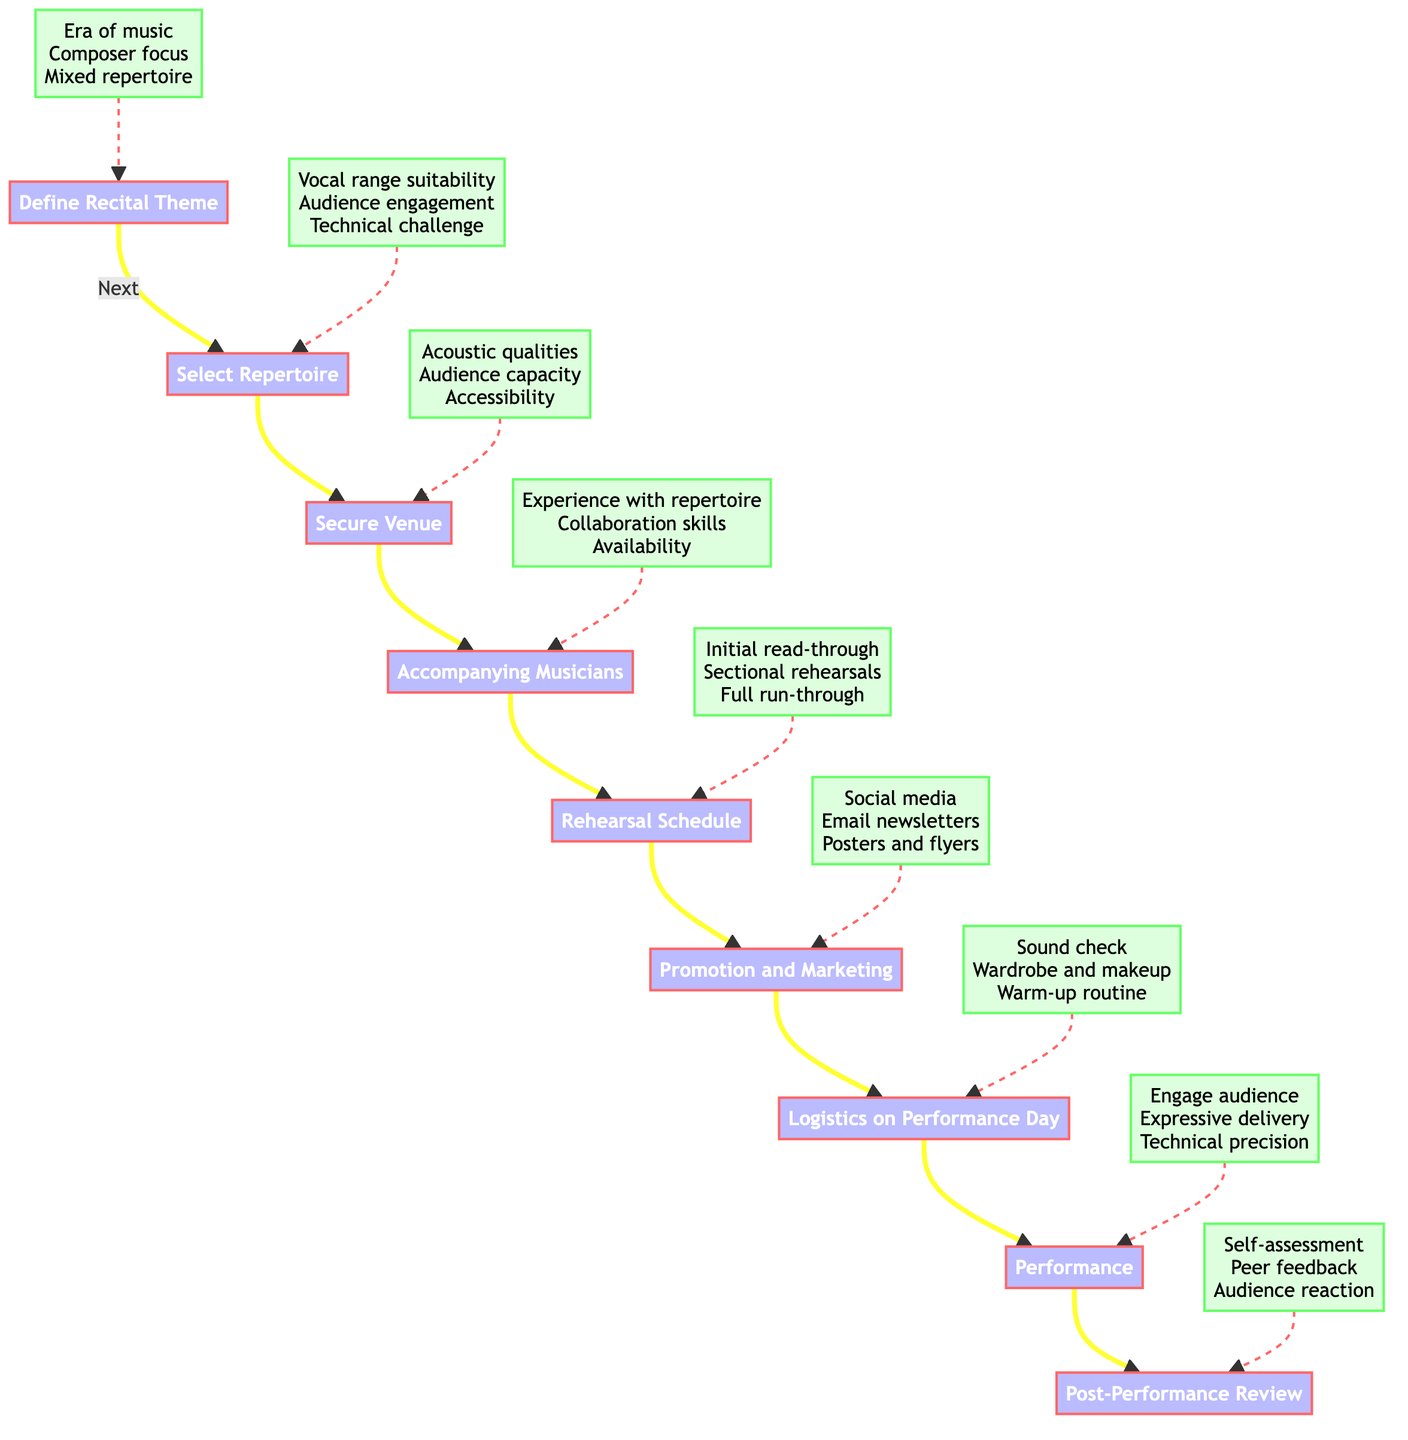What is the first step in planning a recital? The diagram shows that the first step, represented by node A, is "Define Recital Theme."
Answer: Define Recital Theme How many steps are there in the recital planning process? The diagram lists a total of eight steps, from defining the theme to post-performance review.
Answer: Eight What consideration is included in the "Select Repertoire" step? Referring to node B1, "Vocal range suitability" is one of the considerations highlighted for selecting repertoire.
Answer: Vocal range suitability What does the "Performance" step focus on? The diagram indicates that the main elements to focus on during the performance include engaging the audience, expressive delivery, and technical precision.
Answer: Engage audience, Expressive delivery, Technical precision What are two examples given for the "Secure Venue" step? From node C, two examples provided for securing a venue are "Carnegie Hall" and "Wigmore Hall."
Answer: Carnegie Hall, Wigmore Hall What kind of feedback is involved in the "Post-Performance Review"? According to node I, "Feedback from peers" is one of the components of the post-performance review process.
Answer: Feedback from peers Which step follows "Rehearsal Schedule"? The diagram shows that after the "Rehearsal Schedule," the next step is "Promotion and Marketing."
Answer: Promotion and Marketing What should be one of the tasks on the performance day? The tasks listed at node G1 include "Sound check," which is a crucial task on the performance day.
Answer: Sound check What is recommended in the "Promotion and Marketing" step? The diagram suggests using "Social media" as one of the channels for promotion and marketing the recital.
Answer: Social media 